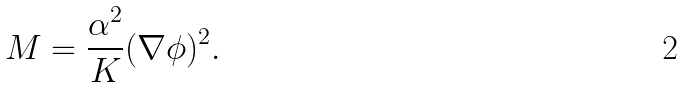<formula> <loc_0><loc_0><loc_500><loc_500>M = \frac { \alpha ^ { 2 } } { K } ( \nabla \phi ) ^ { 2 } .</formula> 